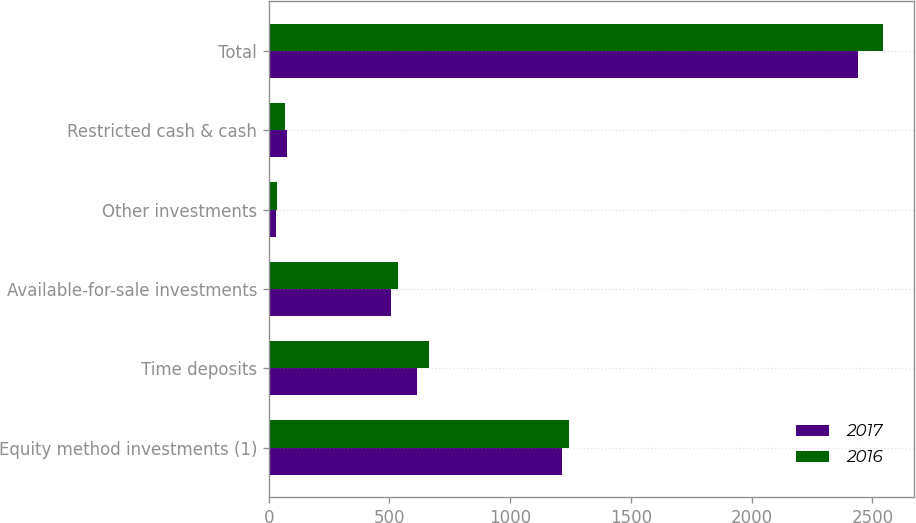Convert chart to OTSL. <chart><loc_0><loc_0><loc_500><loc_500><stacked_bar_chart><ecel><fcel>Equity method investments (1)<fcel>Time deposits<fcel>Available-for-sale investments<fcel>Other investments<fcel>Restricted cash & cash<fcel>Total<nl><fcel>2017<fcel>1214<fcel>613<fcel>508<fcel>30<fcel>74<fcel>2439<nl><fcel>2016<fcel>1242<fcel>665<fcel>537<fcel>33<fcel>68<fcel>2545<nl></chart> 